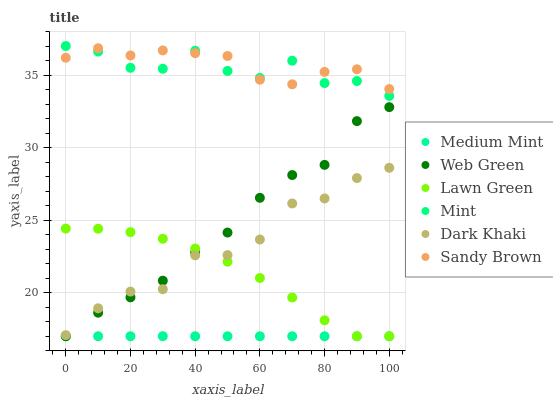Does Medium Mint have the minimum area under the curve?
Answer yes or no. Yes. Does Sandy Brown have the maximum area under the curve?
Answer yes or no. Yes. Does Lawn Green have the minimum area under the curve?
Answer yes or no. No. Does Lawn Green have the maximum area under the curve?
Answer yes or no. No. Is Medium Mint the smoothest?
Answer yes or no. Yes. Is Mint the roughest?
Answer yes or no. Yes. Is Lawn Green the smoothest?
Answer yes or no. No. Is Lawn Green the roughest?
Answer yes or no. No. Does Medium Mint have the lowest value?
Answer yes or no. Yes. Does Mint have the lowest value?
Answer yes or no. No. Does Mint have the highest value?
Answer yes or no. Yes. Does Lawn Green have the highest value?
Answer yes or no. No. Is Lawn Green less than Mint?
Answer yes or no. Yes. Is Mint greater than Web Green?
Answer yes or no. Yes. Does Dark Khaki intersect Lawn Green?
Answer yes or no. Yes. Is Dark Khaki less than Lawn Green?
Answer yes or no. No. Is Dark Khaki greater than Lawn Green?
Answer yes or no. No. Does Lawn Green intersect Mint?
Answer yes or no. No. 